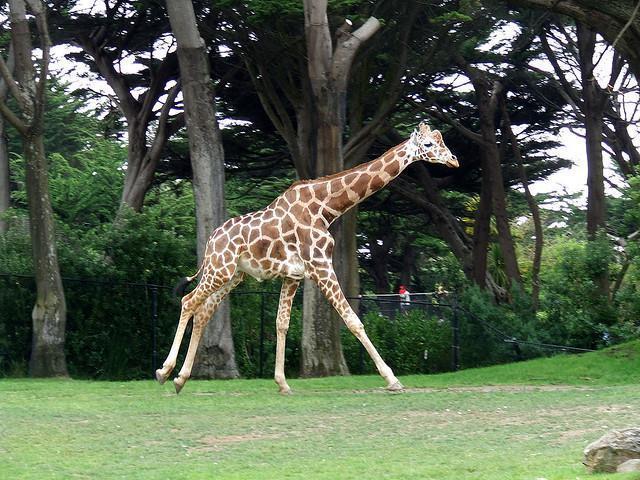How many giraffes are there?
Give a very brief answer. 1. How many birds are flying around?
Give a very brief answer. 0. 